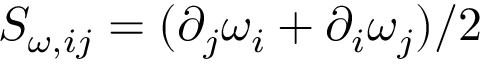Convert formula to latex. <formula><loc_0><loc_0><loc_500><loc_500>S _ { \omega , i j } = ( \partial _ { j } \omega _ { i } + \partial _ { i } \omega _ { j } ) / 2</formula> 